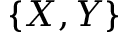Convert formula to latex. <formula><loc_0><loc_0><loc_500><loc_500>\{ X , Y \}</formula> 